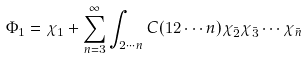<formula> <loc_0><loc_0><loc_500><loc_500>\Phi _ { 1 } = \chi _ { 1 } + \sum _ { n = 3 } ^ { \infty } \int _ { 2 \cdots n } C ( 1 2 \cdots n ) \chi _ { \bar { 2 } } \chi _ { \bar { 3 } } \cdots \chi _ { \bar { n } } \</formula> 